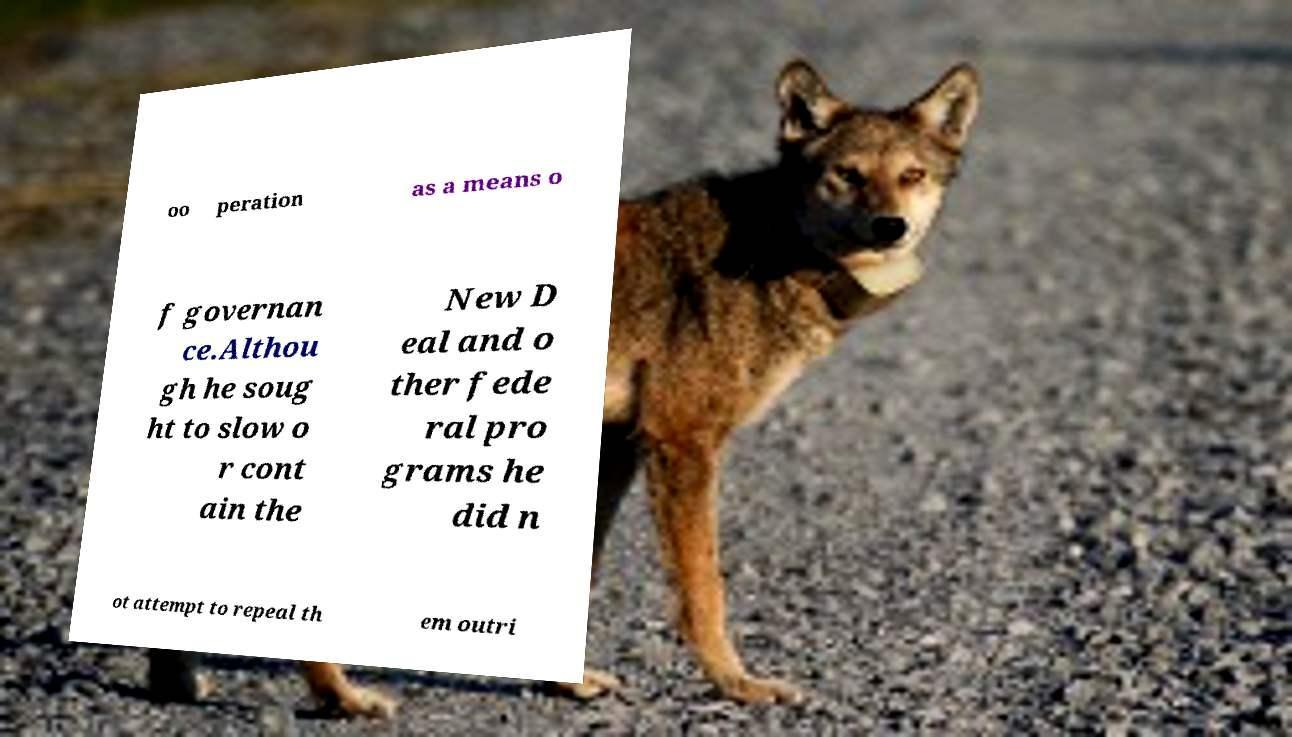Please read and relay the text visible in this image. What does it say? oo peration as a means o f governan ce.Althou gh he soug ht to slow o r cont ain the New D eal and o ther fede ral pro grams he did n ot attempt to repeal th em outri 